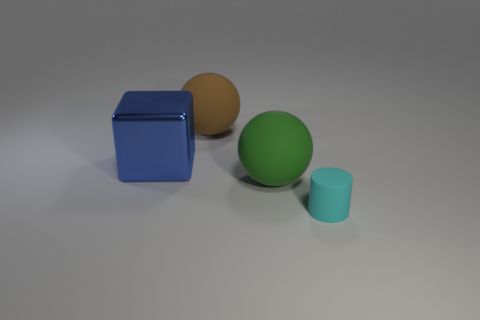What can you infer about the texture of the objects? The objects appear to have a matte finish with smooth surfaces, as indicated by the diffuse reflections and absence of strong specular highlights. 